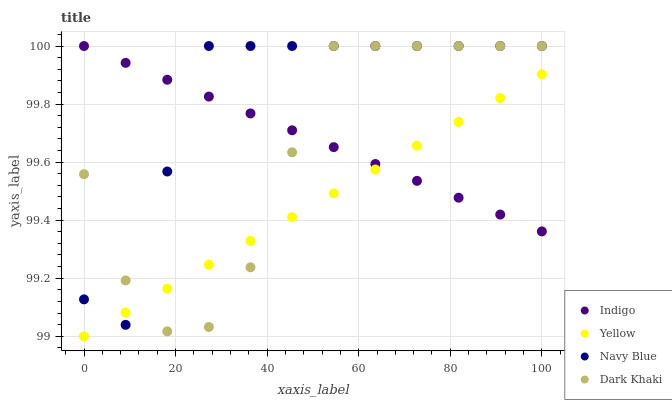Does Yellow have the minimum area under the curve?
Answer yes or no. Yes. Does Navy Blue have the maximum area under the curve?
Answer yes or no. Yes. Does Indigo have the minimum area under the curve?
Answer yes or no. No. Does Indigo have the maximum area under the curve?
Answer yes or no. No. Is Yellow the smoothest?
Answer yes or no. Yes. Is Dark Khaki the roughest?
Answer yes or no. Yes. Is Navy Blue the smoothest?
Answer yes or no. No. Is Navy Blue the roughest?
Answer yes or no. No. Does Yellow have the lowest value?
Answer yes or no. Yes. Does Navy Blue have the lowest value?
Answer yes or no. No. Does Indigo have the highest value?
Answer yes or no. Yes. Does Yellow have the highest value?
Answer yes or no. No. Does Dark Khaki intersect Navy Blue?
Answer yes or no. Yes. Is Dark Khaki less than Navy Blue?
Answer yes or no. No. Is Dark Khaki greater than Navy Blue?
Answer yes or no. No. 